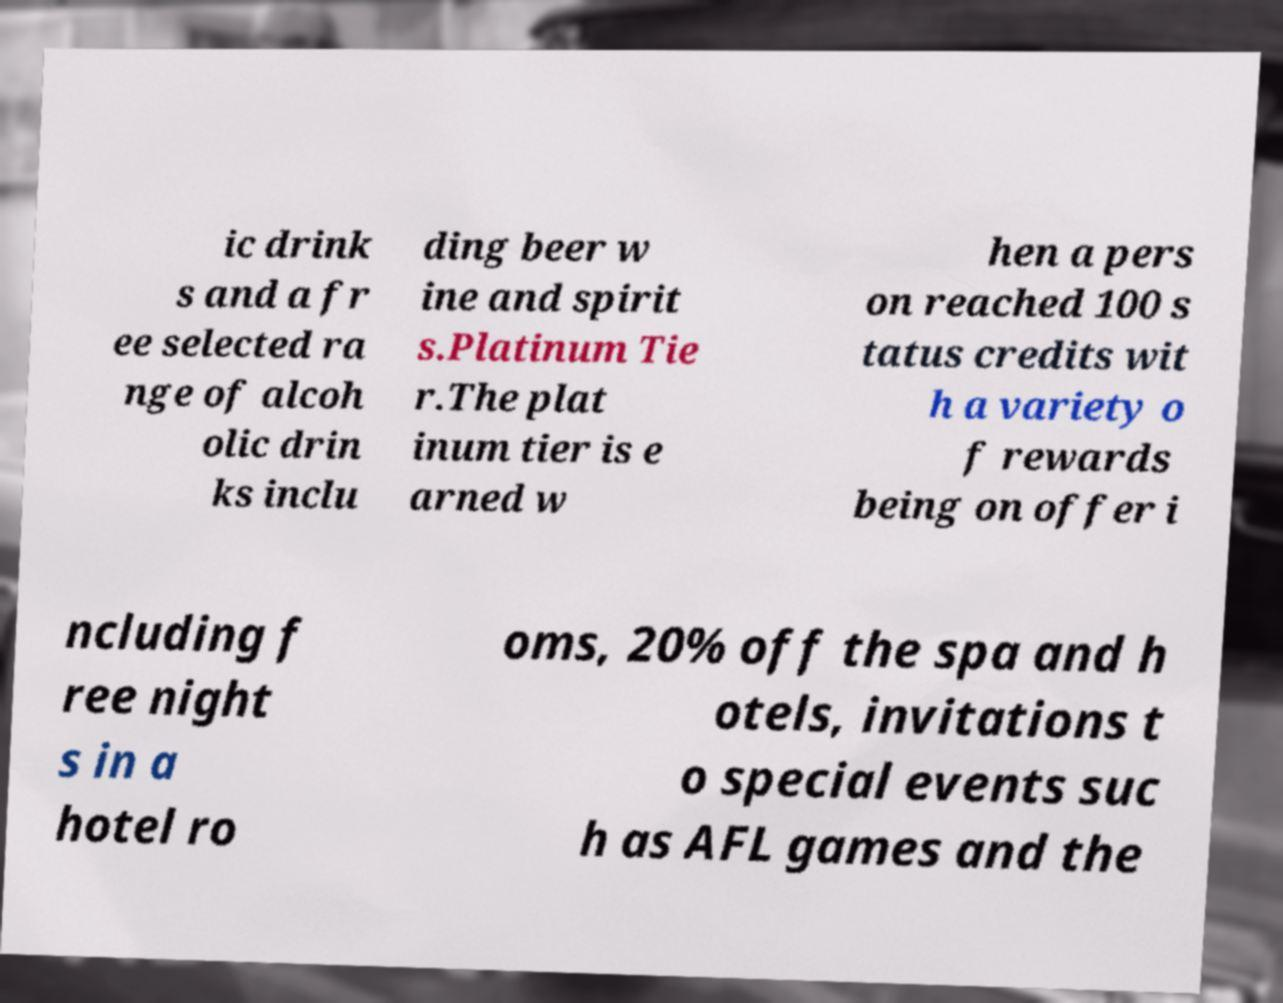There's text embedded in this image that I need extracted. Can you transcribe it verbatim? ic drink s and a fr ee selected ra nge of alcoh olic drin ks inclu ding beer w ine and spirit s.Platinum Tie r.The plat inum tier is e arned w hen a pers on reached 100 s tatus credits wit h a variety o f rewards being on offer i ncluding f ree night s in a hotel ro oms, 20% off the spa and h otels, invitations t o special events suc h as AFL games and the 